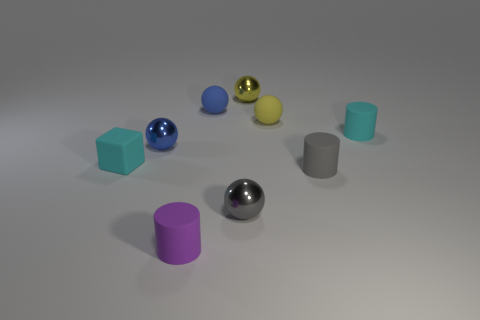Subtract 2 spheres. How many spheres are left? 3 Subtract all cyan balls. Subtract all cyan cylinders. How many balls are left? 5 Add 1 purple objects. How many objects exist? 10 Subtract all cylinders. How many objects are left? 6 Add 3 blue metallic spheres. How many blue metallic spheres are left? 4 Add 4 small cyan rubber things. How many small cyan rubber things exist? 6 Subtract 0 brown spheres. How many objects are left? 9 Subtract all metal balls. Subtract all cyan cylinders. How many objects are left? 5 